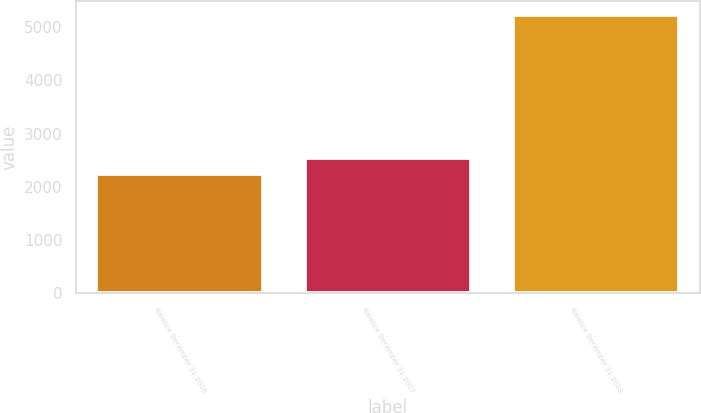Convert chart. <chart><loc_0><loc_0><loc_500><loc_500><bar_chart><fcel>Balance December 31 2006<fcel>Balance December 31 2007<fcel>Balance December 31 2008<nl><fcel>2244.7<fcel>2542.73<fcel>5225<nl></chart> 